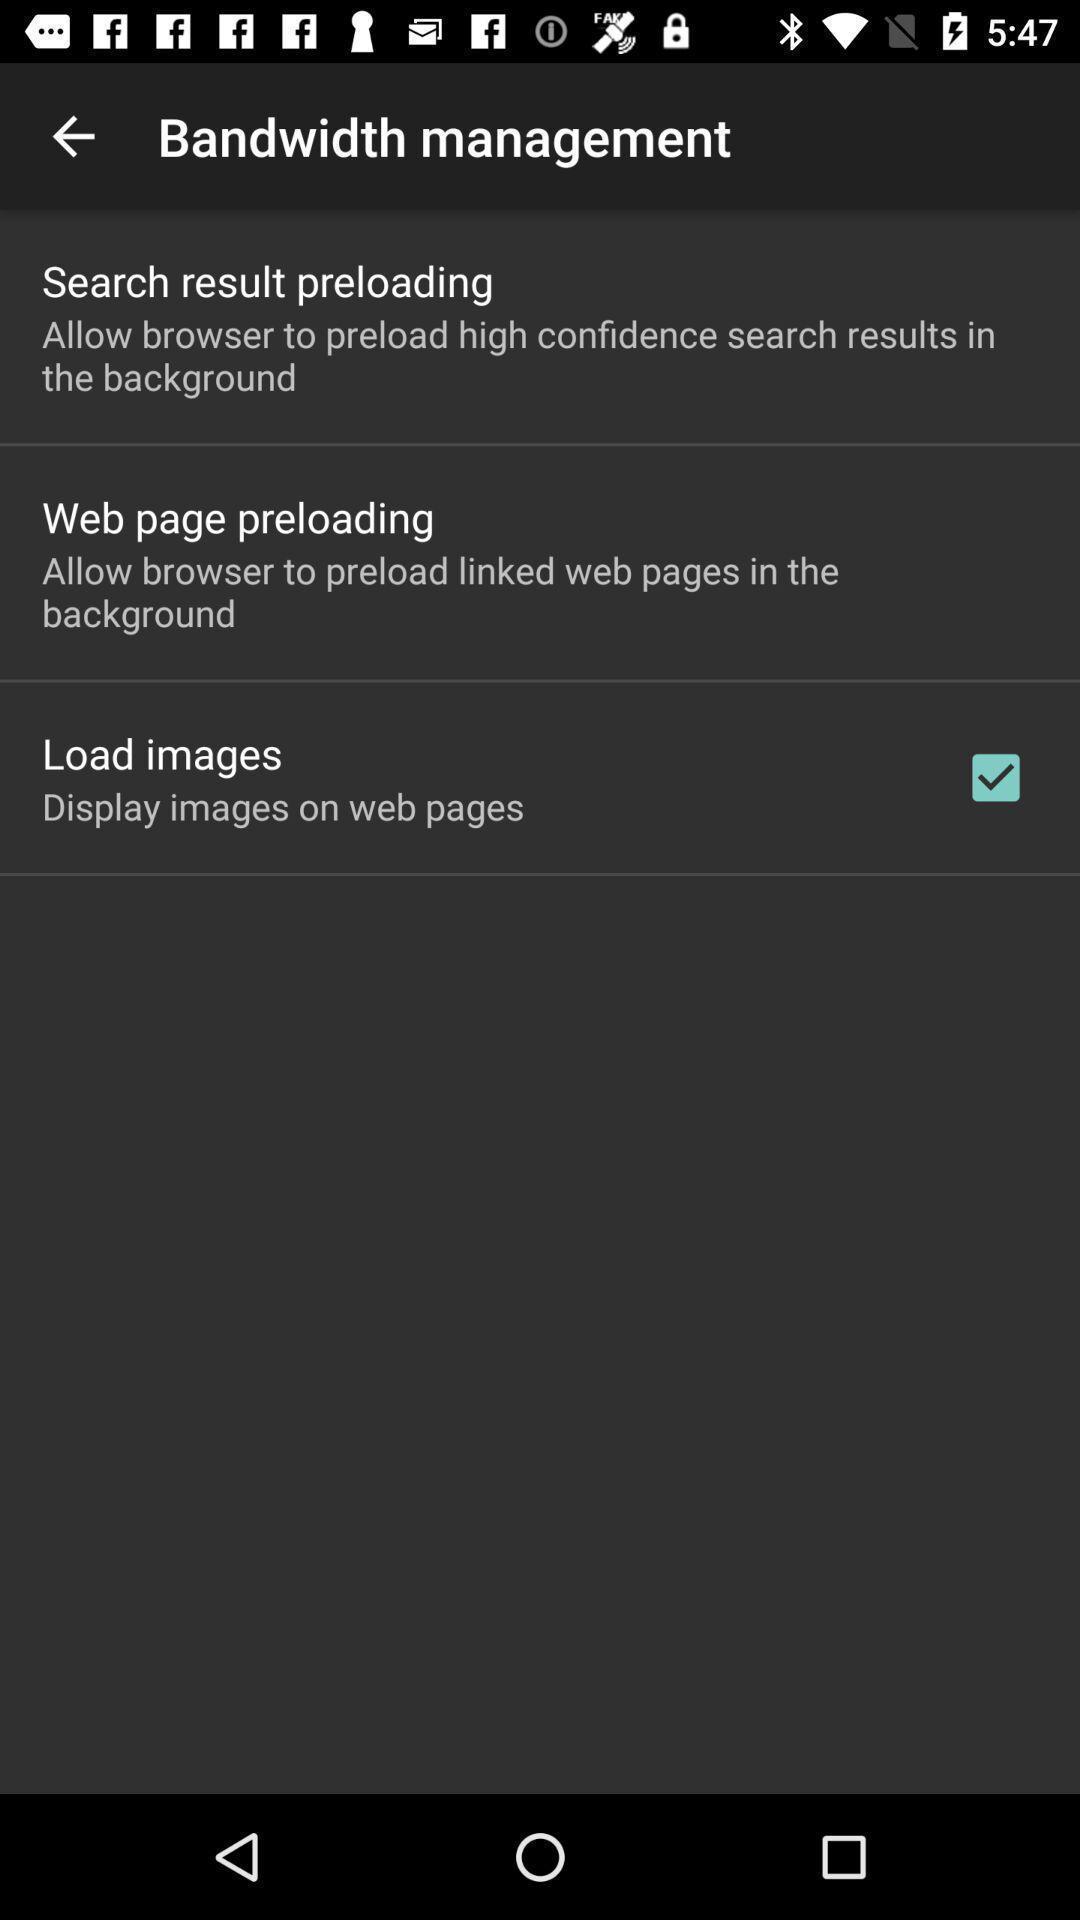Describe this image in words. Screen showing various options. 